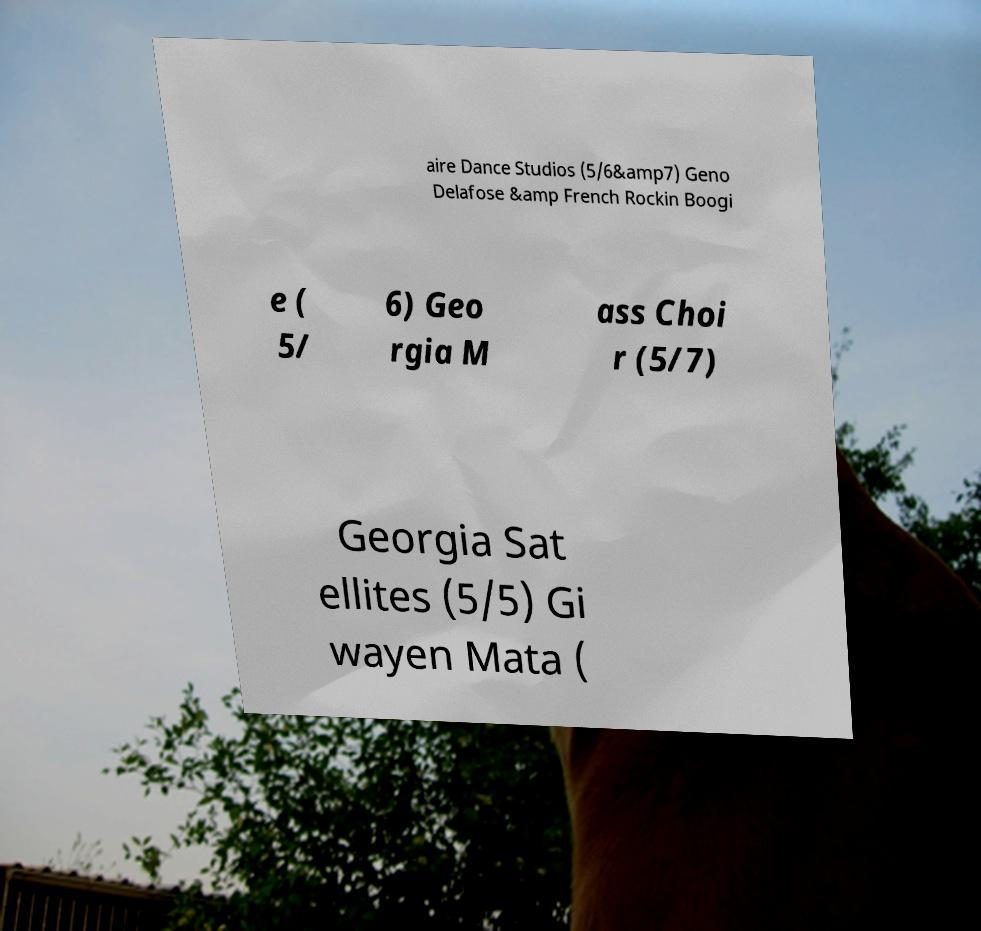Could you assist in decoding the text presented in this image and type it out clearly? aire Dance Studios (5/6&amp7) Geno Delafose &amp French Rockin Boogi e ( 5/ 6) Geo rgia M ass Choi r (5/7) Georgia Sat ellites (5/5) Gi wayen Mata ( 